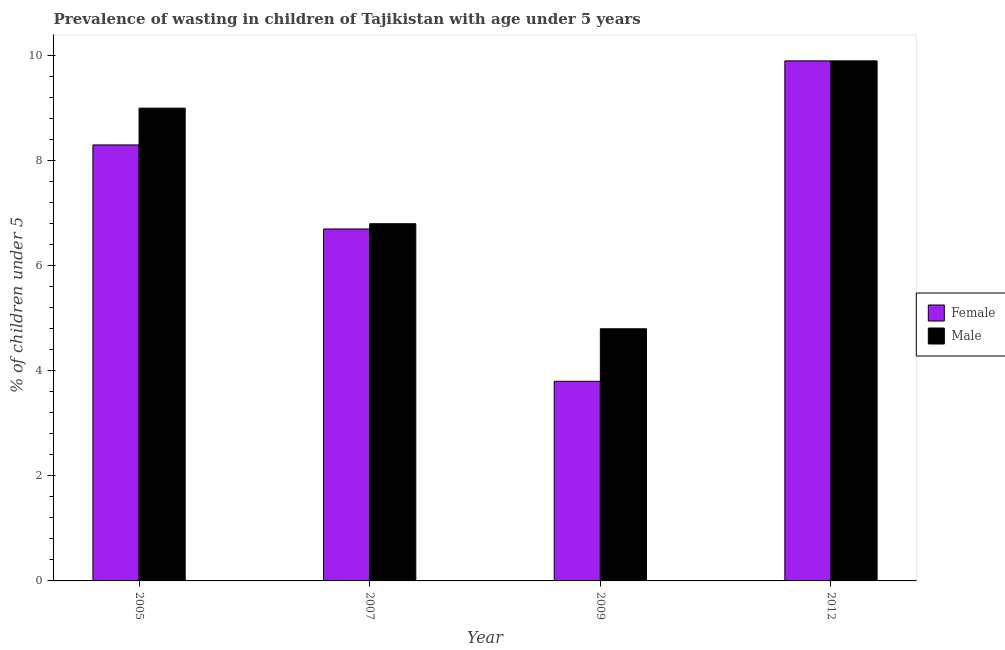How many groups of bars are there?
Ensure brevity in your answer.  4. Are the number of bars per tick equal to the number of legend labels?
Your answer should be compact. Yes. Are the number of bars on each tick of the X-axis equal?
Provide a short and direct response. Yes. How many bars are there on the 4th tick from the left?
Keep it short and to the point. 2. In how many cases, is the number of bars for a given year not equal to the number of legend labels?
Offer a very short reply. 0. What is the percentage of undernourished female children in 2009?
Your answer should be very brief. 3.8. Across all years, what is the maximum percentage of undernourished male children?
Your answer should be very brief. 9.9. Across all years, what is the minimum percentage of undernourished male children?
Ensure brevity in your answer.  4.8. In which year was the percentage of undernourished female children maximum?
Offer a terse response. 2012. In which year was the percentage of undernourished male children minimum?
Your answer should be compact. 2009. What is the total percentage of undernourished female children in the graph?
Provide a succinct answer. 28.7. What is the difference between the percentage of undernourished female children in 2005 and that in 2012?
Make the answer very short. -1.6. What is the difference between the percentage of undernourished female children in 2009 and the percentage of undernourished male children in 2012?
Your answer should be compact. -6.1. What is the average percentage of undernourished male children per year?
Provide a short and direct response. 7.62. In how many years, is the percentage of undernourished male children greater than 4.4 %?
Keep it short and to the point. 4. What is the ratio of the percentage of undernourished male children in 2007 to that in 2009?
Give a very brief answer. 1.42. Is the difference between the percentage of undernourished male children in 2005 and 2007 greater than the difference between the percentage of undernourished female children in 2005 and 2007?
Provide a succinct answer. No. What is the difference between the highest and the second highest percentage of undernourished female children?
Your response must be concise. 1.6. What is the difference between the highest and the lowest percentage of undernourished female children?
Keep it short and to the point. 6.1. In how many years, is the percentage of undernourished female children greater than the average percentage of undernourished female children taken over all years?
Offer a very short reply. 2. Is the sum of the percentage of undernourished female children in 2005 and 2009 greater than the maximum percentage of undernourished male children across all years?
Make the answer very short. Yes. What does the 1st bar from the left in 2009 represents?
Give a very brief answer. Female. What does the 2nd bar from the right in 2005 represents?
Ensure brevity in your answer.  Female. Are all the bars in the graph horizontal?
Ensure brevity in your answer.  No. How many legend labels are there?
Your answer should be compact. 2. How are the legend labels stacked?
Keep it short and to the point. Vertical. What is the title of the graph?
Provide a short and direct response. Prevalence of wasting in children of Tajikistan with age under 5 years. What is the label or title of the Y-axis?
Offer a terse response.  % of children under 5. What is the  % of children under 5 of Female in 2005?
Your response must be concise. 8.3. What is the  % of children under 5 in Female in 2007?
Offer a very short reply. 6.7. What is the  % of children under 5 in Male in 2007?
Give a very brief answer. 6.8. What is the  % of children under 5 of Female in 2009?
Your response must be concise. 3.8. What is the  % of children under 5 of Male in 2009?
Make the answer very short. 4.8. What is the  % of children under 5 of Female in 2012?
Provide a succinct answer. 9.9. What is the  % of children under 5 of Male in 2012?
Offer a terse response. 9.9. Across all years, what is the maximum  % of children under 5 in Female?
Provide a succinct answer. 9.9. Across all years, what is the maximum  % of children under 5 in Male?
Ensure brevity in your answer.  9.9. Across all years, what is the minimum  % of children under 5 in Female?
Keep it short and to the point. 3.8. Across all years, what is the minimum  % of children under 5 of Male?
Keep it short and to the point. 4.8. What is the total  % of children under 5 of Female in the graph?
Your response must be concise. 28.7. What is the total  % of children under 5 of Male in the graph?
Your answer should be compact. 30.5. What is the difference between the  % of children under 5 in Male in 2005 and that in 2007?
Your answer should be very brief. 2.2. What is the difference between the  % of children under 5 in Male in 2005 and that in 2009?
Offer a terse response. 4.2. What is the difference between the  % of children under 5 of Female in 2005 and that in 2012?
Provide a succinct answer. -1.6. What is the difference between the  % of children under 5 of Male in 2005 and that in 2012?
Ensure brevity in your answer.  -0.9. What is the difference between the  % of children under 5 in Female in 2007 and that in 2009?
Your response must be concise. 2.9. What is the difference between the  % of children under 5 in Male in 2007 and that in 2009?
Your answer should be very brief. 2. What is the difference between the  % of children under 5 of Female in 2007 and that in 2012?
Offer a terse response. -3.2. What is the difference between the  % of children under 5 of Male in 2007 and that in 2012?
Keep it short and to the point. -3.1. What is the difference between the  % of children under 5 of Female in 2009 and that in 2012?
Make the answer very short. -6.1. What is the difference between the  % of children under 5 in Male in 2009 and that in 2012?
Give a very brief answer. -5.1. What is the difference between the  % of children under 5 of Female in 2005 and the  % of children under 5 of Male in 2009?
Offer a very short reply. 3.5. What is the difference between the  % of children under 5 in Female in 2007 and the  % of children under 5 in Male in 2009?
Offer a terse response. 1.9. What is the difference between the  % of children under 5 of Female in 2009 and the  % of children under 5 of Male in 2012?
Your answer should be very brief. -6.1. What is the average  % of children under 5 of Female per year?
Your response must be concise. 7.17. What is the average  % of children under 5 of Male per year?
Your answer should be very brief. 7.62. In the year 2005, what is the difference between the  % of children under 5 of Female and  % of children under 5 of Male?
Your response must be concise. -0.7. What is the ratio of the  % of children under 5 of Female in 2005 to that in 2007?
Keep it short and to the point. 1.24. What is the ratio of the  % of children under 5 in Male in 2005 to that in 2007?
Provide a short and direct response. 1.32. What is the ratio of the  % of children under 5 of Female in 2005 to that in 2009?
Offer a terse response. 2.18. What is the ratio of the  % of children under 5 of Male in 2005 to that in 2009?
Your answer should be compact. 1.88. What is the ratio of the  % of children under 5 in Female in 2005 to that in 2012?
Your answer should be very brief. 0.84. What is the ratio of the  % of children under 5 of Male in 2005 to that in 2012?
Offer a very short reply. 0.91. What is the ratio of the  % of children under 5 in Female in 2007 to that in 2009?
Keep it short and to the point. 1.76. What is the ratio of the  % of children under 5 of Male in 2007 to that in 2009?
Make the answer very short. 1.42. What is the ratio of the  % of children under 5 of Female in 2007 to that in 2012?
Your response must be concise. 0.68. What is the ratio of the  % of children under 5 in Male in 2007 to that in 2012?
Your response must be concise. 0.69. What is the ratio of the  % of children under 5 of Female in 2009 to that in 2012?
Provide a short and direct response. 0.38. What is the ratio of the  % of children under 5 in Male in 2009 to that in 2012?
Offer a terse response. 0.48. What is the difference between the highest and the second highest  % of children under 5 in Male?
Your answer should be very brief. 0.9. What is the difference between the highest and the lowest  % of children under 5 of Female?
Keep it short and to the point. 6.1. What is the difference between the highest and the lowest  % of children under 5 of Male?
Offer a very short reply. 5.1. 